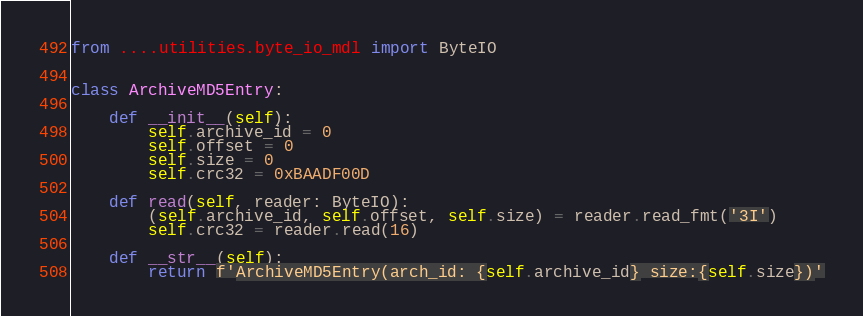Convert code to text. <code><loc_0><loc_0><loc_500><loc_500><_Python_>from ....utilities.byte_io_mdl import ByteIO


class ArchiveMD5Entry:

    def __init__(self):
        self.archive_id = 0
        self.offset = 0
        self.size = 0
        self.crc32 = 0xBAADF00D

    def read(self, reader: ByteIO):
        (self.archive_id, self.offset, self.size) = reader.read_fmt('3I')
        self.crc32 = reader.read(16)

    def __str__(self):
        return f'ArchiveMD5Entry(arch_id: {self.archive_id} size:{self.size})'
</code> 